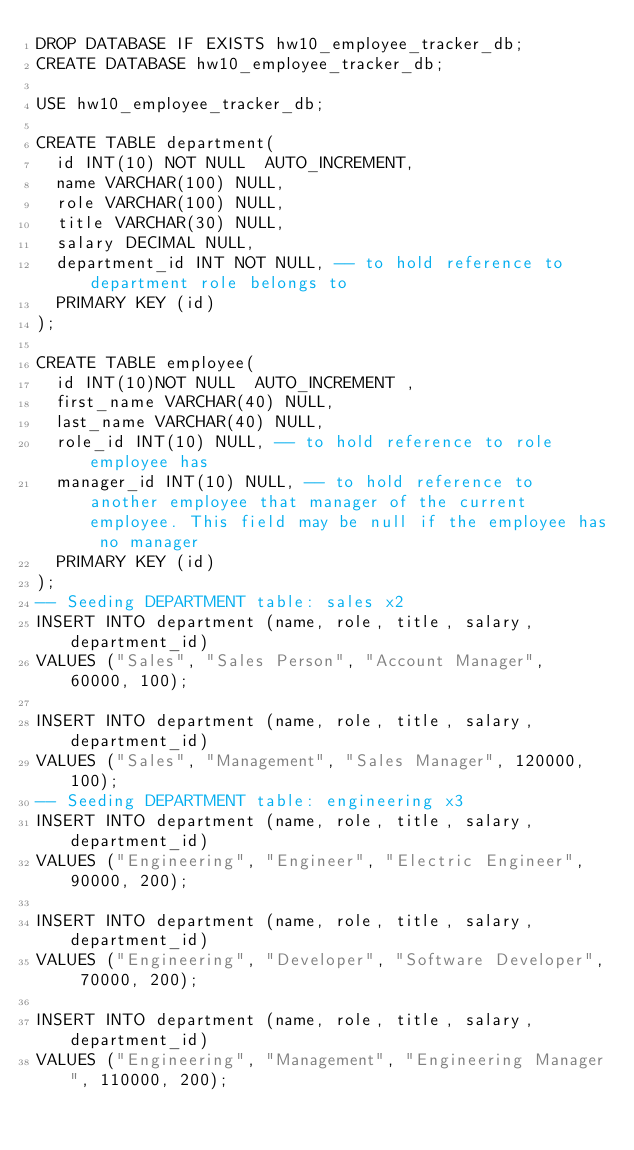<code> <loc_0><loc_0><loc_500><loc_500><_SQL_>DROP DATABASE IF EXISTS hw10_employee_tracker_db;
CREATE DATABASE hw10_employee_tracker_db;

USE hw10_employee_tracker_db;

CREATE TABLE department(
  id INT(10) NOT NULL  AUTO_INCREMENT,
  name VARCHAR(100) NULL,
  role VARCHAR(100) NULL,
  title VARCHAR(30) NULL,
  salary DECIMAL NULL,
  department_id INT NOT NULL, -- to hold reference to department role belongs to
  PRIMARY KEY (id)
);

CREATE TABLE employee(
  id INT(10)NOT NULL  AUTO_INCREMENT ,
  first_name VARCHAR(40) NULL,
  last_name VARCHAR(40) NULL,
  role_id INT(10) NULL, -- to hold reference to role employee has
  manager_id INT(10) NULL, -- to hold reference to another employee that manager of the current employee. This field may be null if the employee has no manager
  PRIMARY KEY (id) 
);
-- Seeding DEPARTMENT table: sales x2
INSERT INTO department (name, role, title, salary, department_id)
VALUES ("Sales", "Sales Person", "Account Manager", 60000, 100);

INSERT INTO department (name, role, title, salary, department_id)
VALUES ("Sales", "Management", "Sales Manager", 120000, 100);
-- Seeding DEPARTMENT table: engineering x3
INSERT INTO department (name, role, title, salary, department_id)
VALUES ("Engineering", "Engineer", "Electric Engineer", 90000, 200);

INSERT INTO department (name, role, title, salary, department_id)
VALUES ("Engineering", "Developer", "Software Developer", 70000, 200);

INSERT INTO department (name, role, title, salary, department_id)
VALUES ("Engineering", "Management", "Engineering Manager", 110000, 200);</code> 